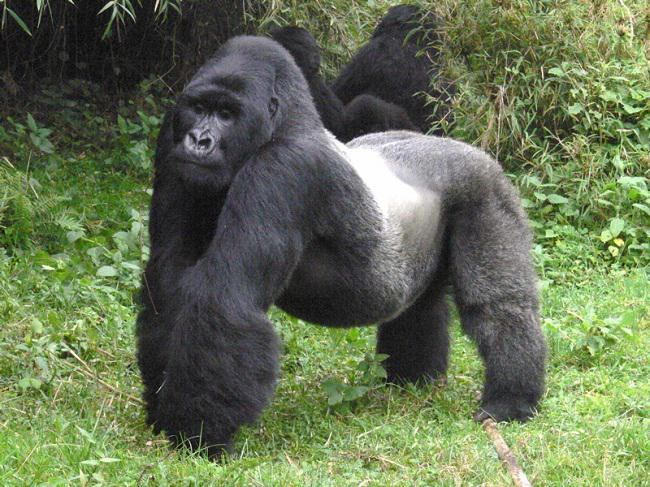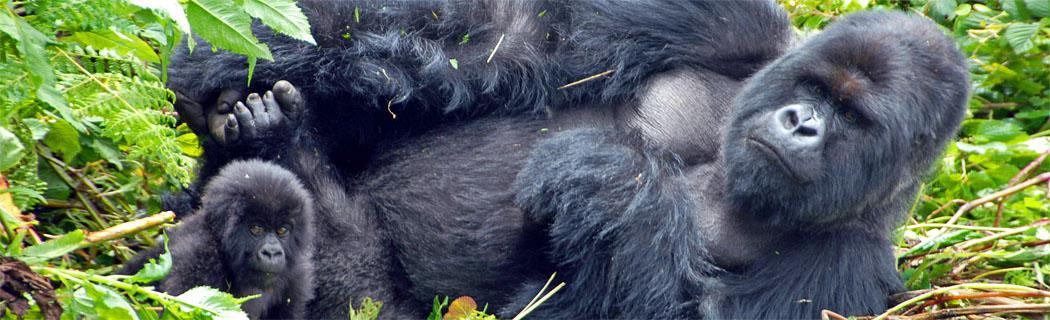The first image is the image on the left, the second image is the image on the right. Considering the images on both sides, is "There are two adult gorillas and one baby gorilla in one of the images." valid? Answer yes or no. No. 